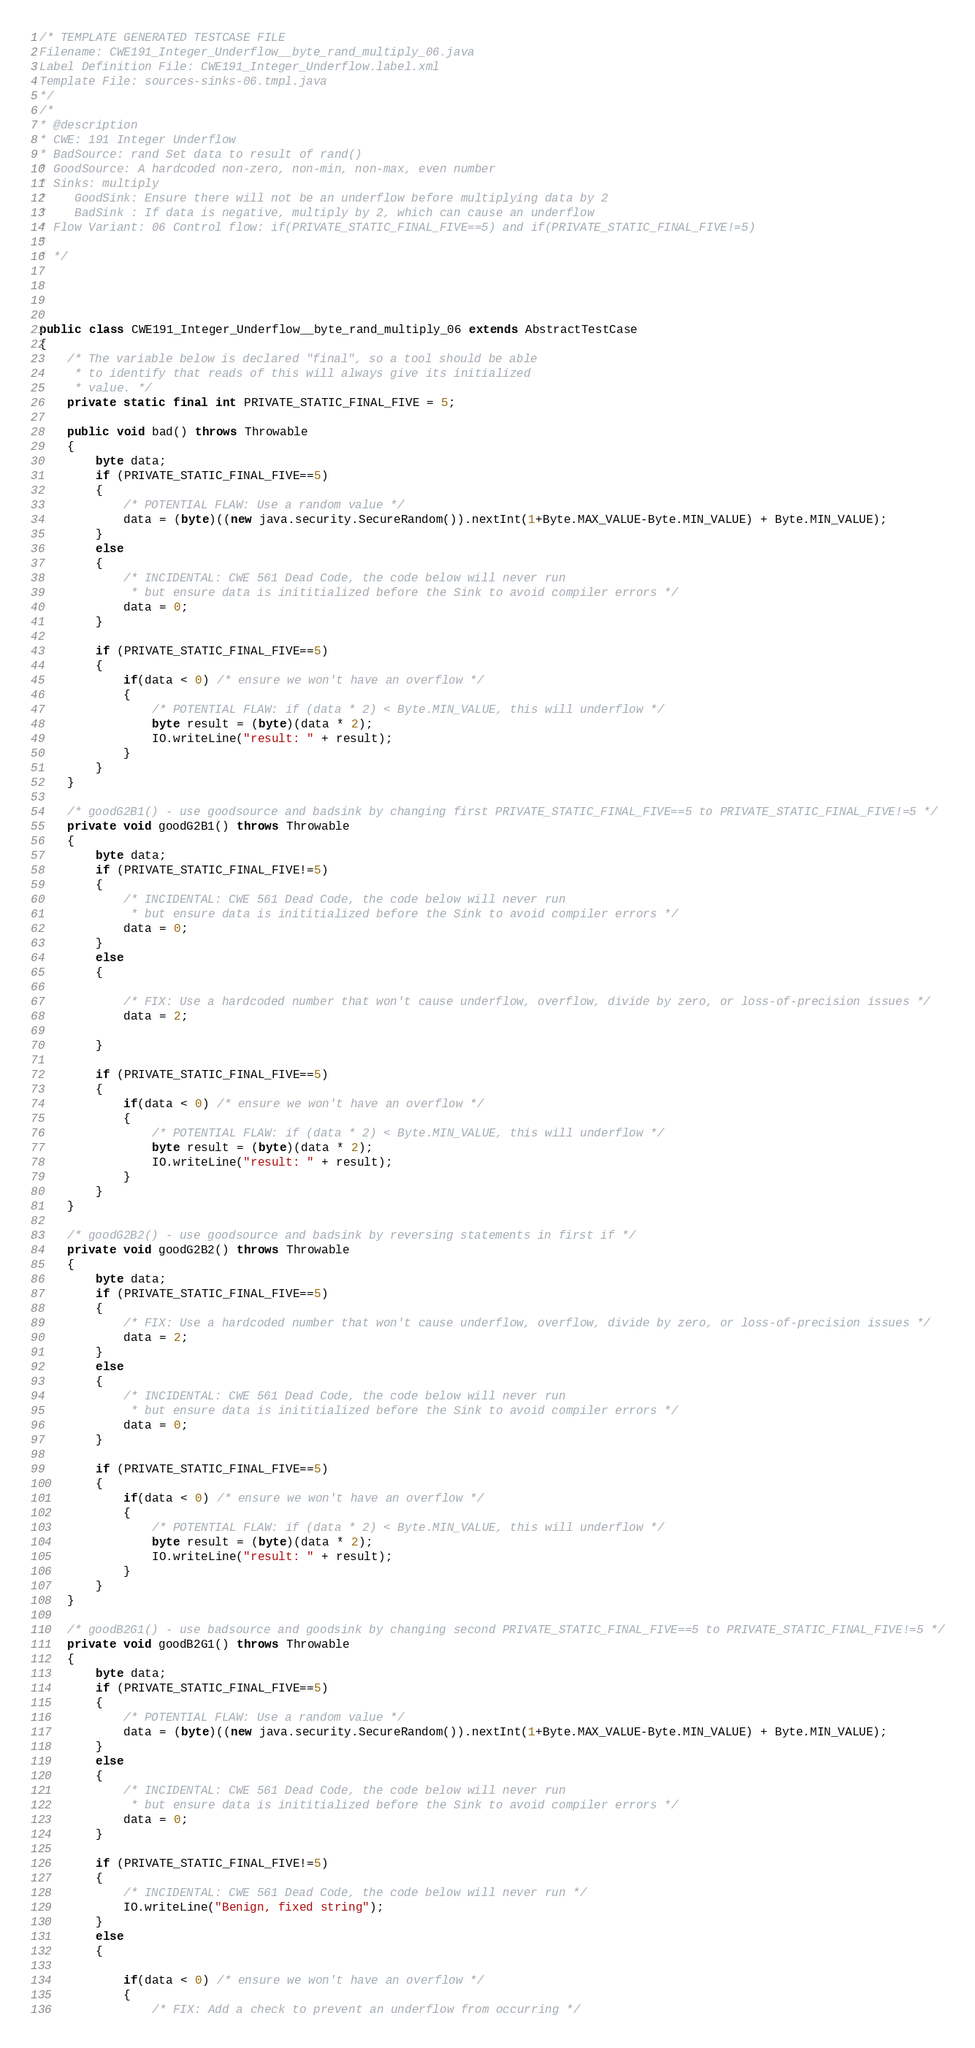<code> <loc_0><loc_0><loc_500><loc_500><_Java_>/* TEMPLATE GENERATED TESTCASE FILE
Filename: CWE191_Integer_Underflow__byte_rand_multiply_06.java
Label Definition File: CWE191_Integer_Underflow.label.xml
Template File: sources-sinks-06.tmpl.java
*/
/*
* @description
* CWE: 191 Integer Underflow
* BadSource: rand Set data to result of rand()
* GoodSource: A hardcoded non-zero, non-min, non-max, even number
* Sinks: multiply
*    GoodSink: Ensure there will not be an underflow before multiplying data by 2
*    BadSink : If data is negative, multiply by 2, which can cause an underflow
* Flow Variant: 06 Control flow: if(PRIVATE_STATIC_FINAL_FIVE==5) and if(PRIVATE_STATIC_FINAL_FIVE!=5)
*
* */




public class CWE191_Integer_Underflow__byte_rand_multiply_06 extends AbstractTestCase
{
    /* The variable below is declared "final", so a tool should be able
     * to identify that reads of this will always give its initialized
     * value. */
    private static final int PRIVATE_STATIC_FINAL_FIVE = 5;

    public void bad() throws Throwable
    {
        byte data;
        if (PRIVATE_STATIC_FINAL_FIVE==5)
        {
            /* POTENTIAL FLAW: Use a random value */
            data = (byte)((new java.security.SecureRandom()).nextInt(1+Byte.MAX_VALUE-Byte.MIN_VALUE) + Byte.MIN_VALUE);
        }
        else
        {
            /* INCIDENTAL: CWE 561 Dead Code, the code below will never run
             * but ensure data is inititialized before the Sink to avoid compiler errors */
            data = 0;
        }

        if (PRIVATE_STATIC_FINAL_FIVE==5)
        {
            if(data < 0) /* ensure we won't have an overflow */
            {
                /* POTENTIAL FLAW: if (data * 2) < Byte.MIN_VALUE, this will underflow */
                byte result = (byte)(data * 2);
                IO.writeLine("result: " + result);
            }
        }
    }

    /* goodG2B1() - use goodsource and badsink by changing first PRIVATE_STATIC_FINAL_FIVE==5 to PRIVATE_STATIC_FINAL_FIVE!=5 */
    private void goodG2B1() throws Throwable
    {
        byte data;
        if (PRIVATE_STATIC_FINAL_FIVE!=5)
        {
            /* INCIDENTAL: CWE 561 Dead Code, the code below will never run
             * but ensure data is inititialized before the Sink to avoid compiler errors */
            data = 0;
        }
        else
        {

            /* FIX: Use a hardcoded number that won't cause underflow, overflow, divide by zero, or loss-of-precision issues */
            data = 2;

        }

        if (PRIVATE_STATIC_FINAL_FIVE==5)
        {
            if(data < 0) /* ensure we won't have an overflow */
            {
                /* POTENTIAL FLAW: if (data * 2) < Byte.MIN_VALUE, this will underflow */
                byte result = (byte)(data * 2);
                IO.writeLine("result: " + result);
            }
        }
    }

    /* goodG2B2() - use goodsource and badsink by reversing statements in first if */
    private void goodG2B2() throws Throwable
    {
        byte data;
        if (PRIVATE_STATIC_FINAL_FIVE==5)
        {
            /* FIX: Use a hardcoded number that won't cause underflow, overflow, divide by zero, or loss-of-precision issues */
            data = 2;
        }
        else
        {
            /* INCIDENTAL: CWE 561 Dead Code, the code below will never run
             * but ensure data is inititialized before the Sink to avoid compiler errors */
            data = 0;
        }

        if (PRIVATE_STATIC_FINAL_FIVE==5)
        {
            if(data < 0) /* ensure we won't have an overflow */
            {
                /* POTENTIAL FLAW: if (data * 2) < Byte.MIN_VALUE, this will underflow */
                byte result = (byte)(data * 2);
                IO.writeLine("result: " + result);
            }
        }
    }

    /* goodB2G1() - use badsource and goodsink by changing second PRIVATE_STATIC_FINAL_FIVE==5 to PRIVATE_STATIC_FINAL_FIVE!=5 */
    private void goodB2G1() throws Throwable
    {
        byte data;
        if (PRIVATE_STATIC_FINAL_FIVE==5)
        {
            /* POTENTIAL FLAW: Use a random value */
            data = (byte)((new java.security.SecureRandom()).nextInt(1+Byte.MAX_VALUE-Byte.MIN_VALUE) + Byte.MIN_VALUE);
        }
        else
        {
            /* INCIDENTAL: CWE 561 Dead Code, the code below will never run
             * but ensure data is inititialized before the Sink to avoid compiler errors */
            data = 0;
        }

        if (PRIVATE_STATIC_FINAL_FIVE!=5)
        {
            /* INCIDENTAL: CWE 561 Dead Code, the code below will never run */
            IO.writeLine("Benign, fixed string");
        }
        else
        {

            if(data < 0) /* ensure we won't have an overflow */
            {
                /* FIX: Add a check to prevent an underflow from occurring */</code> 